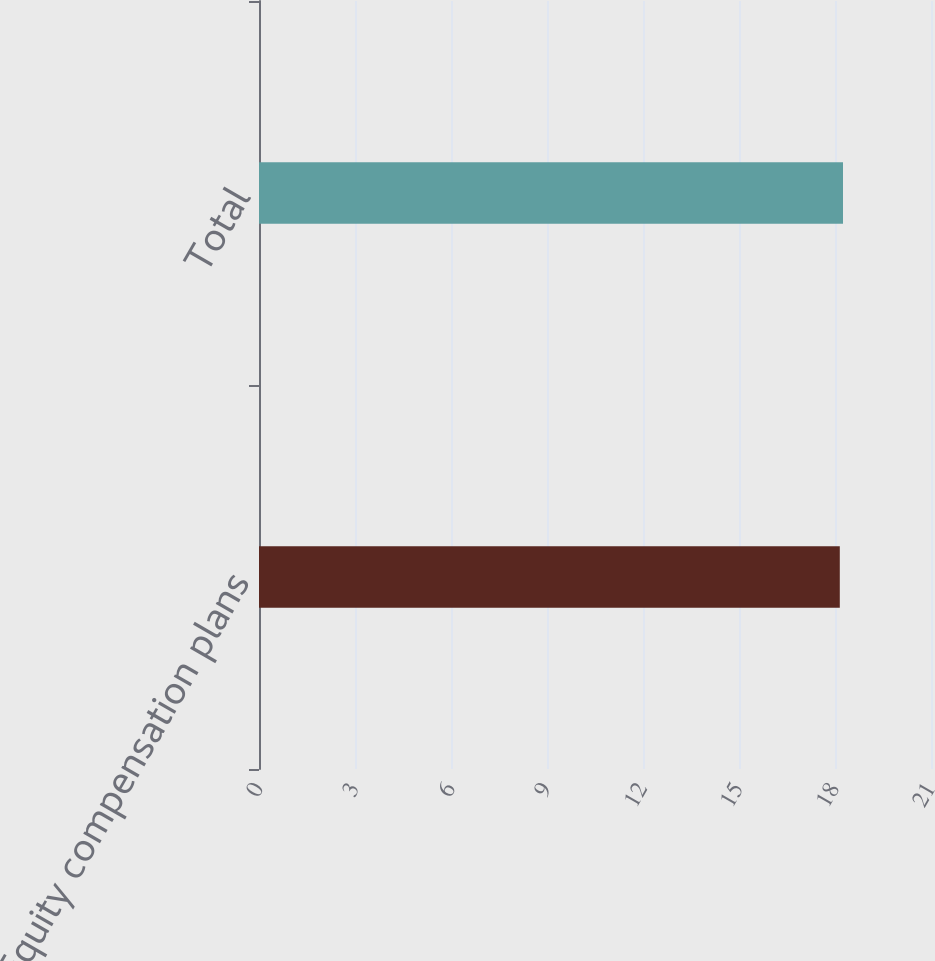<chart> <loc_0><loc_0><loc_500><loc_500><bar_chart><fcel>Equity compensation plans<fcel>Total<nl><fcel>18.15<fcel>18.25<nl></chart> 